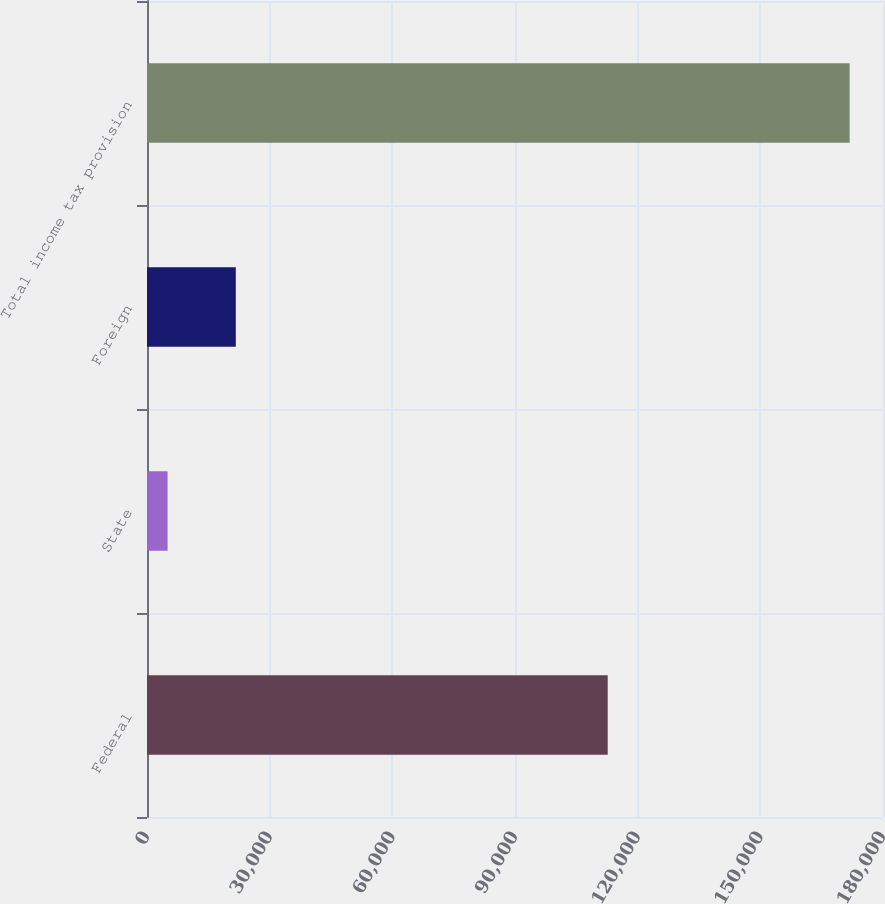Convert chart. <chart><loc_0><loc_0><loc_500><loc_500><bar_chart><fcel>Federal<fcel>State<fcel>Foreign<fcel>Total income tax provision<nl><fcel>112673<fcel>5035<fcel>21715.7<fcel>171842<nl></chart> 